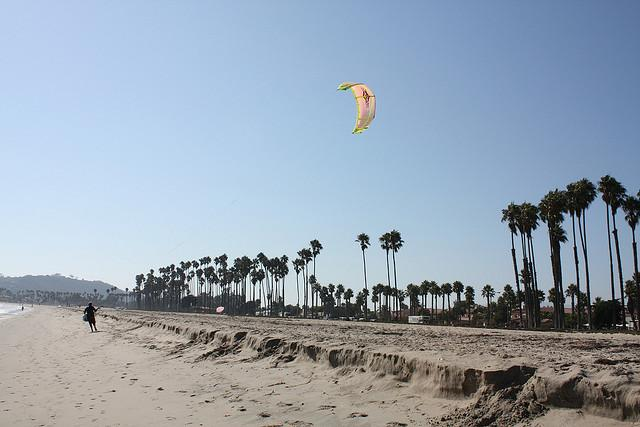What sport can be associated with the above picture? parasailing 